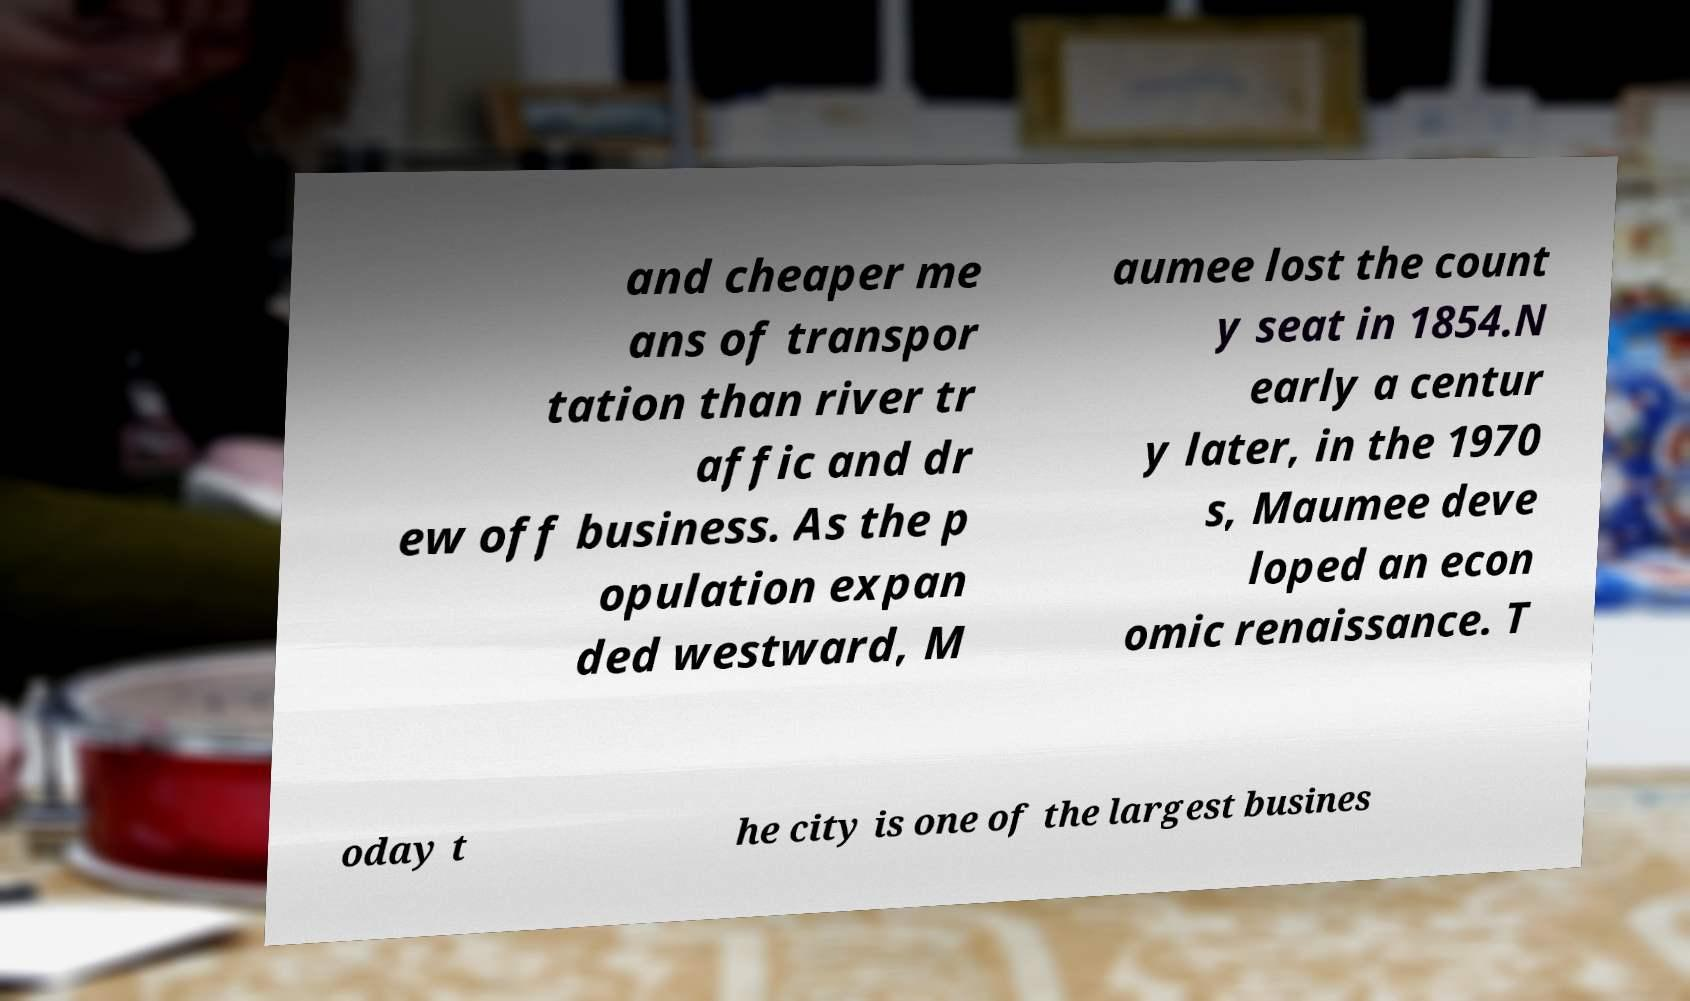Can you read and provide the text displayed in the image?This photo seems to have some interesting text. Can you extract and type it out for me? and cheaper me ans of transpor tation than river tr affic and dr ew off business. As the p opulation expan ded westward, M aumee lost the count y seat in 1854.N early a centur y later, in the 1970 s, Maumee deve loped an econ omic renaissance. T oday t he city is one of the largest busines 